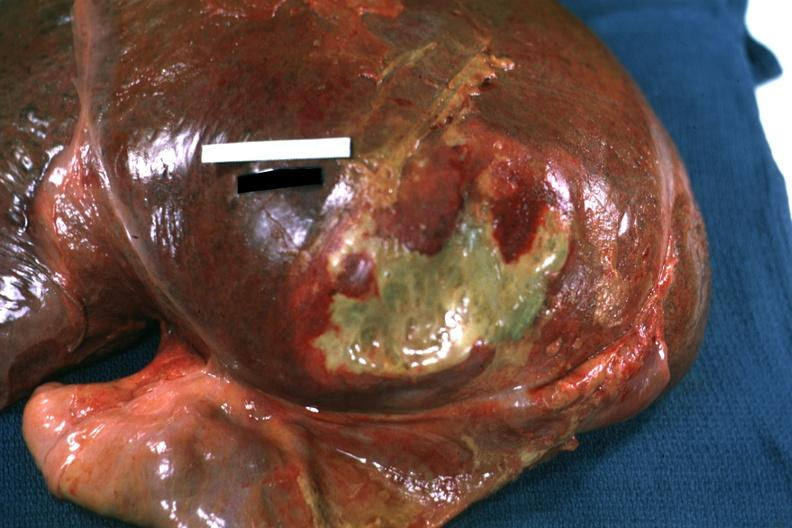what does this image show?
Answer the question using a single word or phrase. Right leaf of diaphragm reflected to show flat mass of yellow green pus quite good example 